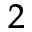<formula> <loc_0><loc_0><loc_500><loc_500>_ { 2 }</formula> 